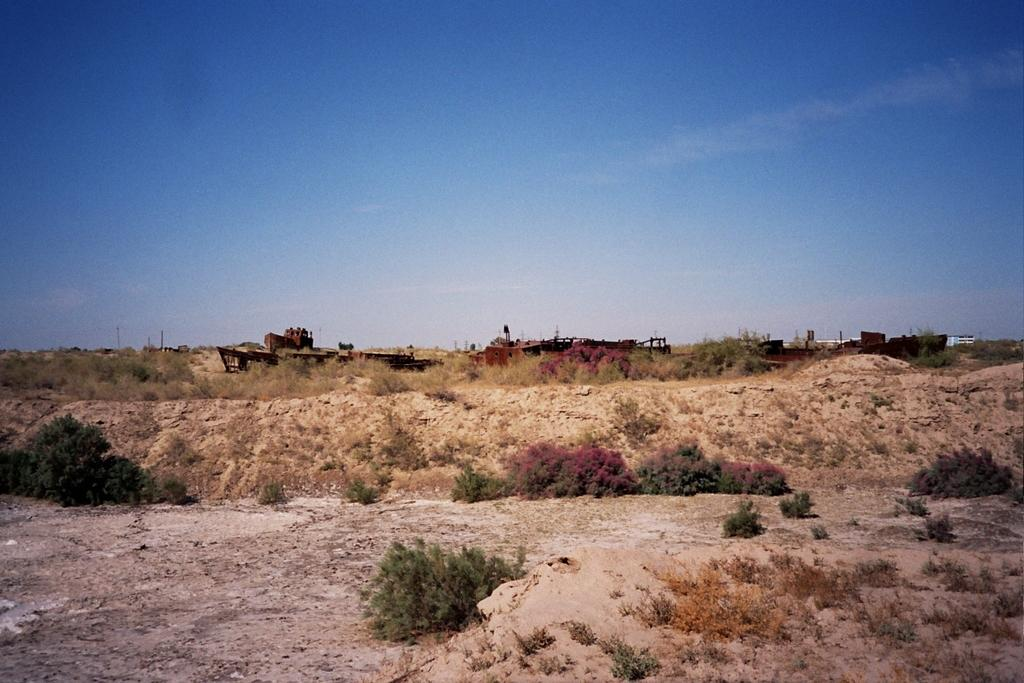What type of vegetation can be seen in the image? There are bushes in the image. What is located at the center of the image? There are unclear objects at the center of the image. What part of the natural environment is visible in the image? The sky is visible in the image. What type of ornament is hanging from the bushes in the image? There is no ornament present in the image; it only features bushes and unclear objects at the center. Can you tell me how many airplanes are visible at the airport in the image? There is no airport or airplanes present in the image; it only features bushes, unclear objects, and the sky. 